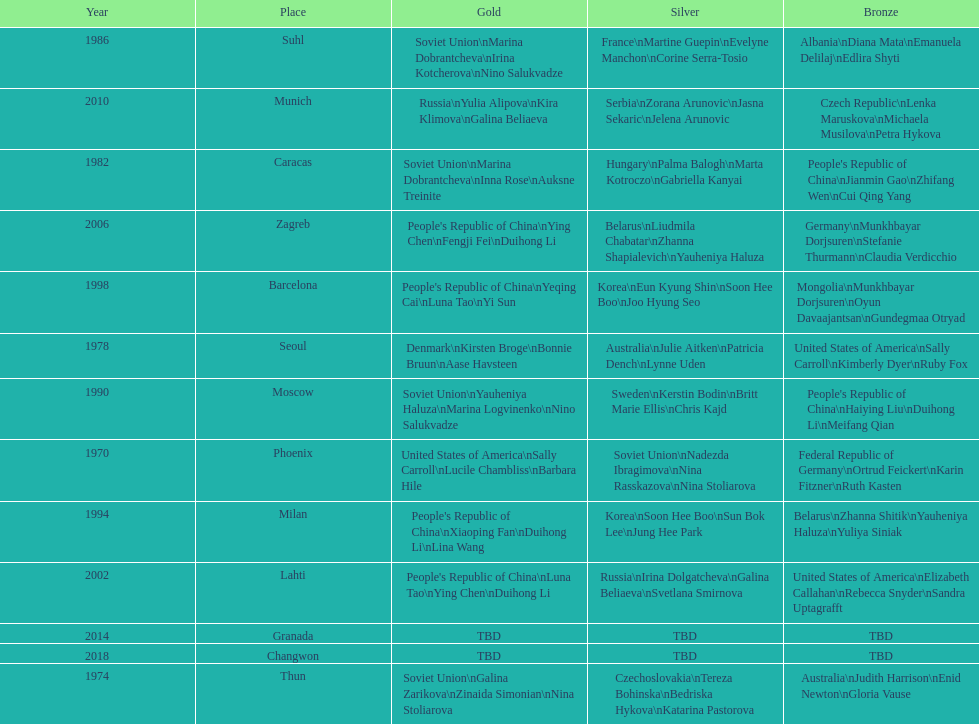Whose name is listed before bonnie bruun's in the gold column? Kirsten Broge. 